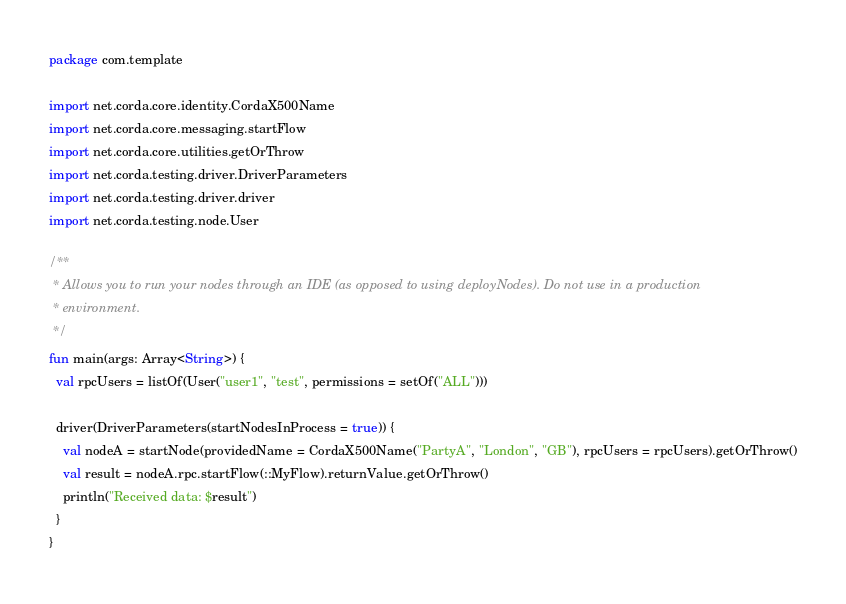Convert code to text. <code><loc_0><loc_0><loc_500><loc_500><_Kotlin_>package com.template

import net.corda.core.identity.CordaX500Name
import net.corda.core.messaging.startFlow
import net.corda.core.utilities.getOrThrow
import net.corda.testing.driver.DriverParameters
import net.corda.testing.driver.driver
import net.corda.testing.node.User

/**
 * Allows you to run your nodes through an IDE (as opposed to using deployNodes). Do not use in a production
 * environment.
 */
fun main(args: Array<String>) {
  val rpcUsers = listOf(User("user1", "test", permissions = setOf("ALL")))

  driver(DriverParameters(startNodesInProcess = true)) {
    val nodeA = startNode(providedName = CordaX500Name("PartyA", "London", "GB"), rpcUsers = rpcUsers).getOrThrow()
    val result = nodeA.rpc.startFlow(::MyFlow).returnValue.getOrThrow()
    println("Received data: $result")
  }
}
</code> 